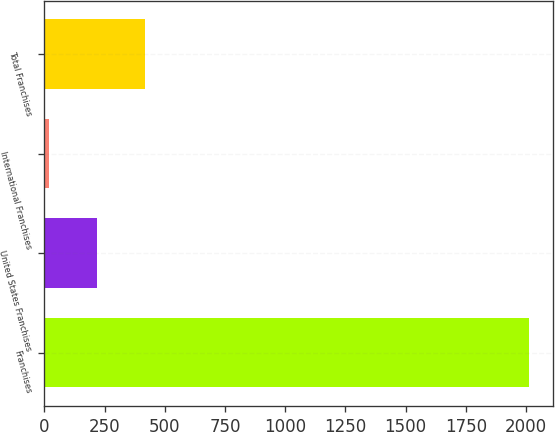Convert chart to OTSL. <chart><loc_0><loc_0><loc_500><loc_500><bar_chart><fcel>Franchises<fcel>United States Franchises<fcel>International Franchises<fcel>Total Franchises<nl><fcel>2011<fcel>217.3<fcel>18<fcel>416.6<nl></chart> 